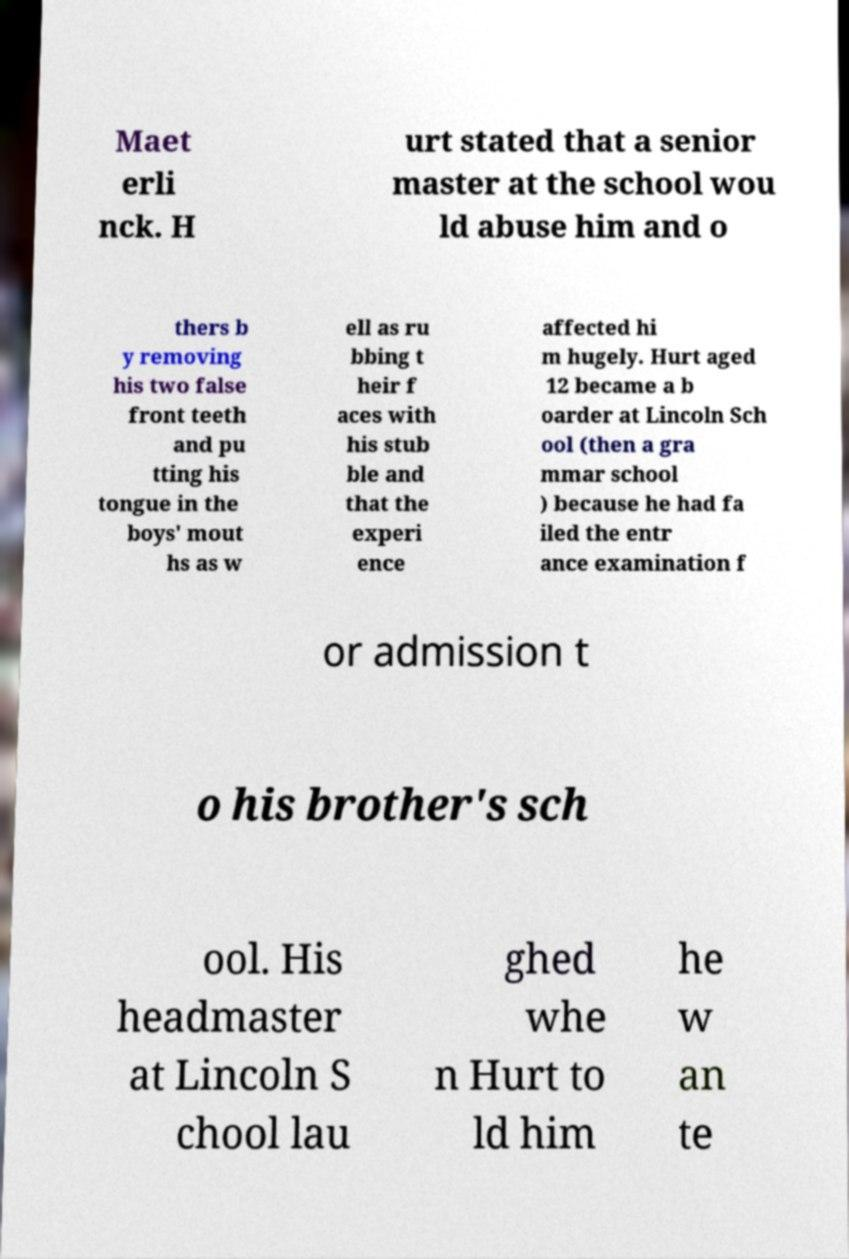What messages or text are displayed in this image? I need them in a readable, typed format. Maet erli nck. H urt stated that a senior master at the school wou ld abuse him and o thers b y removing his two false front teeth and pu tting his tongue in the boys' mout hs as w ell as ru bbing t heir f aces with his stub ble and that the experi ence affected hi m hugely. Hurt aged 12 became a b oarder at Lincoln Sch ool (then a gra mmar school ) because he had fa iled the entr ance examination f or admission t o his brother's sch ool. His headmaster at Lincoln S chool lau ghed whe n Hurt to ld him he w an te 